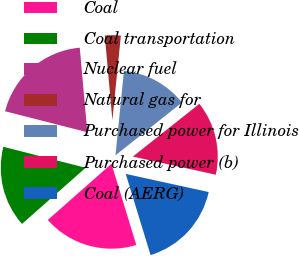<chart> <loc_0><loc_0><loc_500><loc_500><pie_chart><fcel>Coal<fcel>Coal transportation<fcel>Nuclear fuel<fcel>Natural gas for<fcel>Purchased power for Illinois<fcel>Purchased power (b)<fcel>Coal (AERG)<nl><fcel>18.22%<fcel>15.48%<fcel>19.6%<fcel>3.02%<fcel>12.73%<fcel>14.1%<fcel>16.85%<nl></chart> 